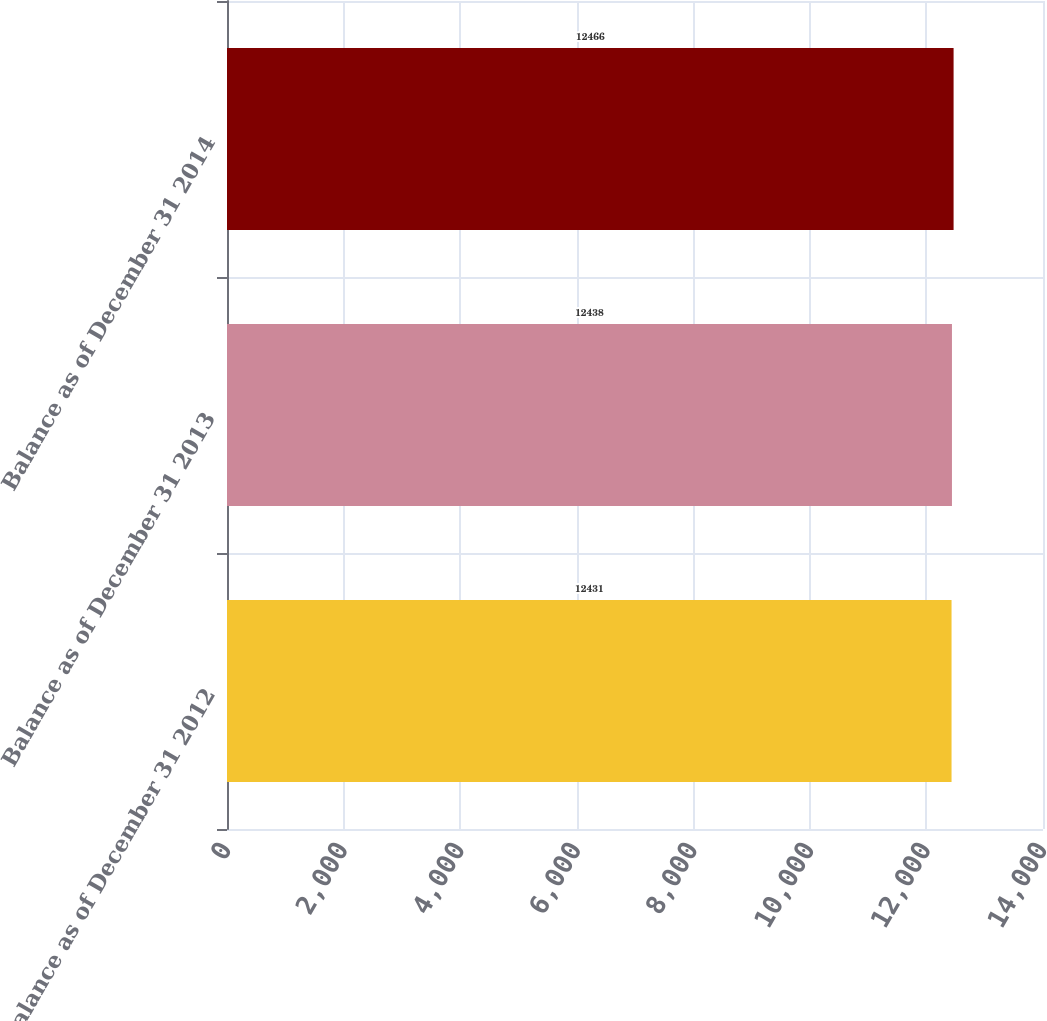Convert chart. <chart><loc_0><loc_0><loc_500><loc_500><bar_chart><fcel>Balance as of December 31 2012<fcel>Balance as of December 31 2013<fcel>Balance as of December 31 2014<nl><fcel>12431<fcel>12438<fcel>12466<nl></chart> 